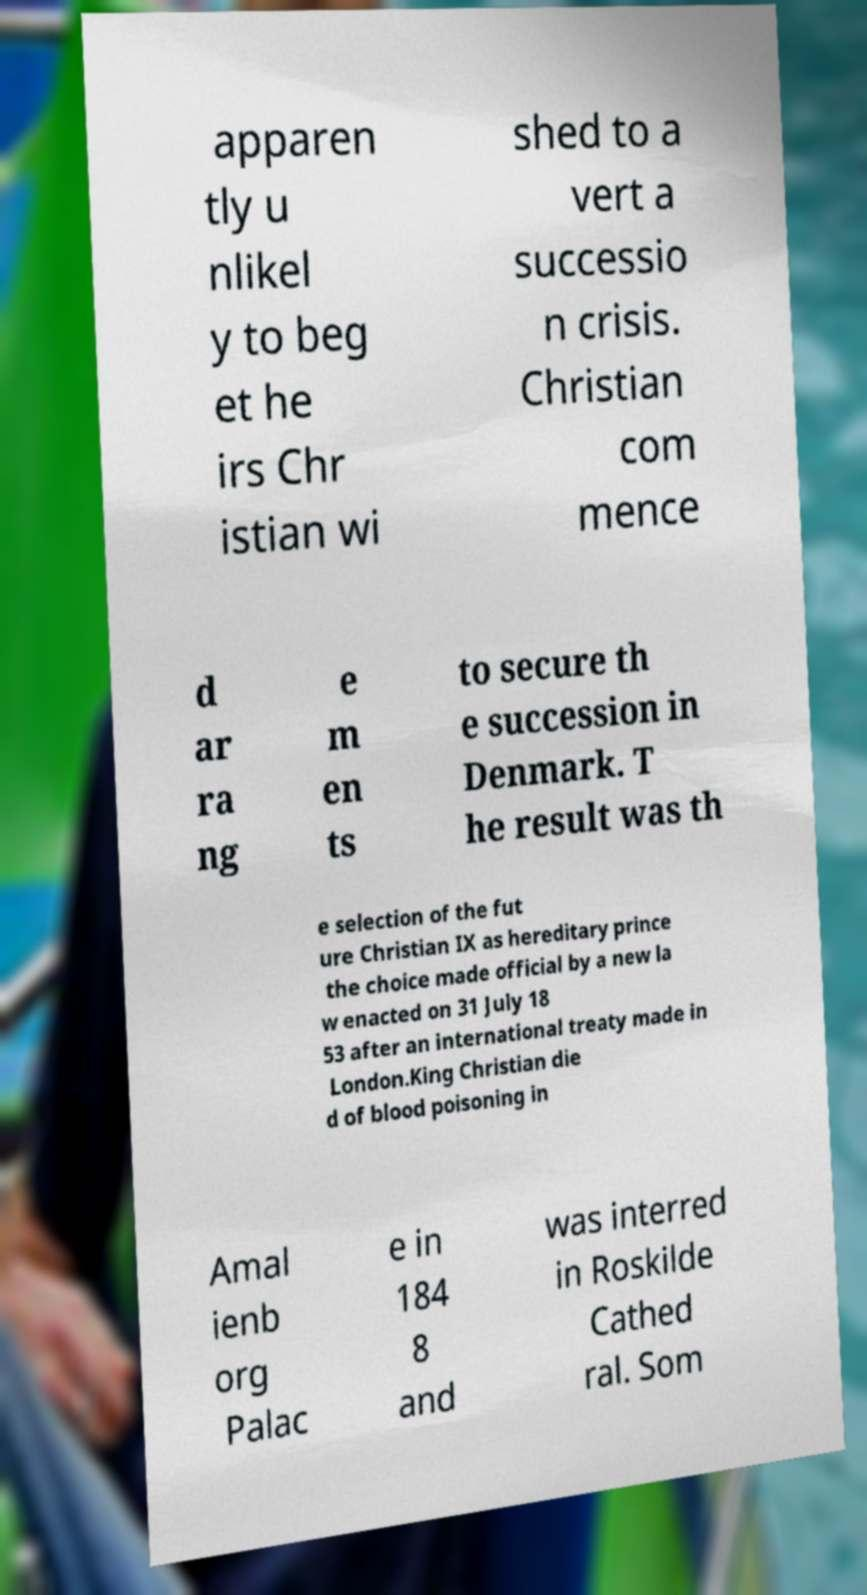There's text embedded in this image that I need extracted. Can you transcribe it verbatim? apparen tly u nlikel y to beg et he irs Chr istian wi shed to a vert a successio n crisis. Christian com mence d ar ra ng e m en ts to secure th e succession in Denmark. T he result was th e selection of the fut ure Christian IX as hereditary prince the choice made official by a new la w enacted on 31 July 18 53 after an international treaty made in London.King Christian die d of blood poisoning in Amal ienb org Palac e in 184 8 and was interred in Roskilde Cathed ral. Som 